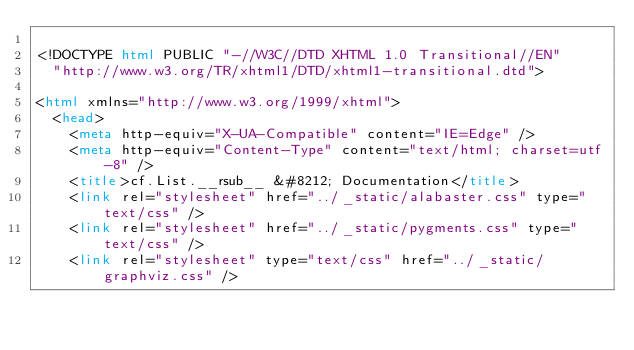Convert code to text. <code><loc_0><loc_0><loc_500><loc_500><_HTML_>
<!DOCTYPE html PUBLIC "-//W3C//DTD XHTML 1.0 Transitional//EN"
  "http://www.w3.org/TR/xhtml1/DTD/xhtml1-transitional.dtd">

<html xmlns="http://www.w3.org/1999/xhtml">
  <head>
    <meta http-equiv="X-UA-Compatible" content="IE=Edge" />
    <meta http-equiv="Content-Type" content="text/html; charset=utf-8" />
    <title>cf.List.__rsub__ &#8212; Documentation</title>
    <link rel="stylesheet" href="../_static/alabaster.css" type="text/css" />
    <link rel="stylesheet" href="../_static/pygments.css" type="text/css" />
    <link rel="stylesheet" type="text/css" href="../_static/graphviz.css" /></code> 